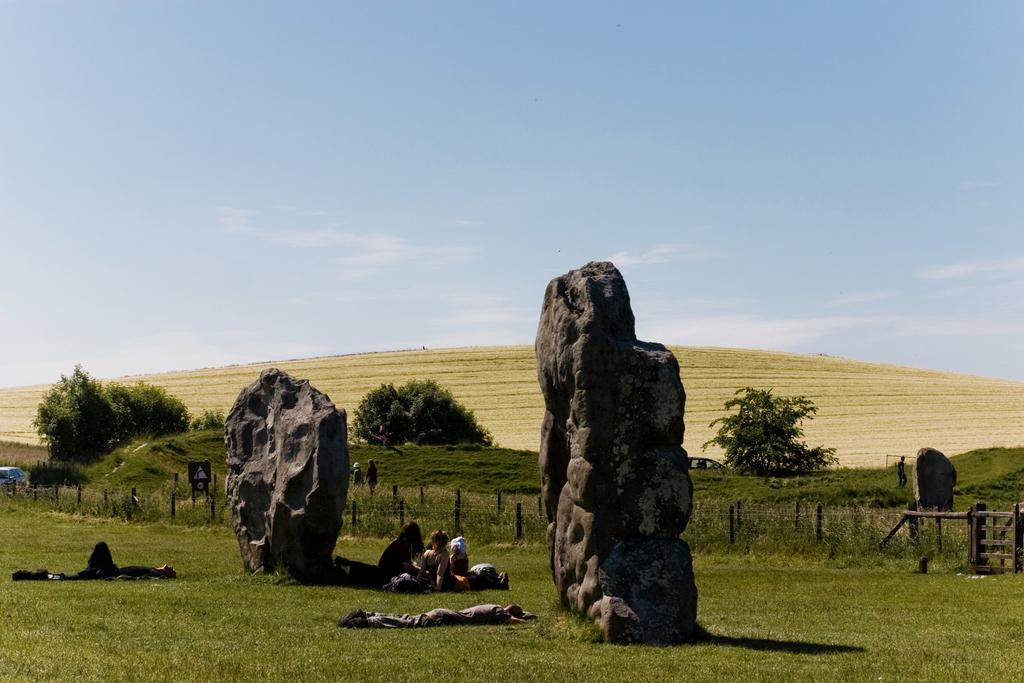What type of natural elements can be seen in the image? There are rocks, grass, and trees in the image. Are there any living beings present in the image? Yes, there are people in the image. What is visible in the background of the image? The sky is visible in the image. What type of party is being held in the image? There is no party present in the image; it features rocks, grass, trees, and people. How many times do the people in the image jump? There is no indication of jumping in the image; the people are simply standing or walking. 